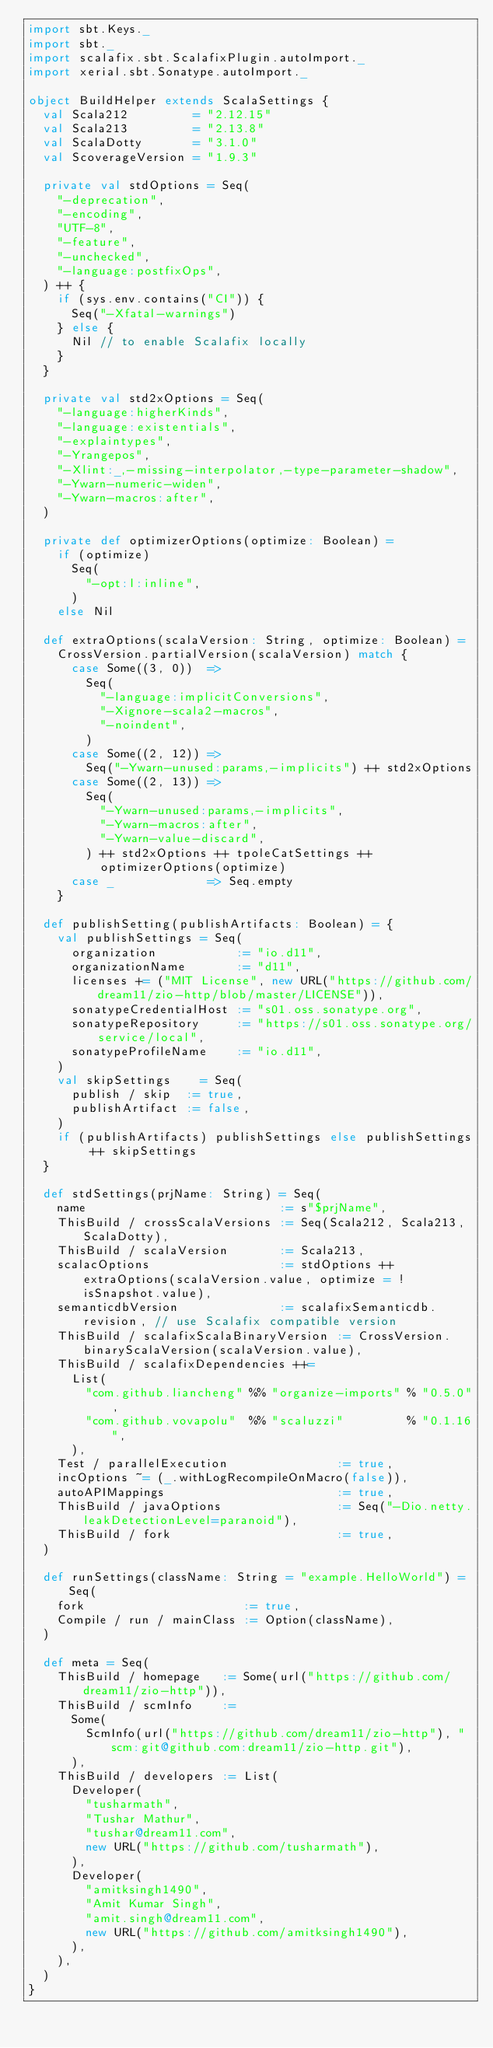<code> <loc_0><loc_0><loc_500><loc_500><_Scala_>import sbt.Keys._
import sbt._
import scalafix.sbt.ScalafixPlugin.autoImport._
import xerial.sbt.Sonatype.autoImport._

object BuildHelper extends ScalaSettings {
  val Scala212         = "2.12.15"
  val Scala213         = "2.13.8"
  val ScalaDotty       = "3.1.0"
  val ScoverageVersion = "1.9.3"

  private val stdOptions = Seq(
    "-deprecation",
    "-encoding",
    "UTF-8",
    "-feature",
    "-unchecked",
    "-language:postfixOps",
  ) ++ {
    if (sys.env.contains("CI")) {
      Seq("-Xfatal-warnings")
    } else {
      Nil // to enable Scalafix locally
    }
  }

  private val std2xOptions = Seq(
    "-language:higherKinds",
    "-language:existentials",
    "-explaintypes",
    "-Yrangepos",
    "-Xlint:_,-missing-interpolator,-type-parameter-shadow",
    "-Ywarn-numeric-widen",
    "-Ywarn-macros:after",
  )

  private def optimizerOptions(optimize: Boolean) =
    if (optimize)
      Seq(
        "-opt:l:inline",
      )
    else Nil

  def extraOptions(scalaVersion: String, optimize: Boolean) =
    CrossVersion.partialVersion(scalaVersion) match {
      case Some((3, 0))  =>
        Seq(
          "-language:implicitConversions",
          "-Xignore-scala2-macros",
          "-noindent",
        )
      case Some((2, 12)) =>
        Seq("-Ywarn-unused:params,-implicits") ++ std2xOptions
      case Some((2, 13)) =>
        Seq(
          "-Ywarn-unused:params,-implicits",
          "-Ywarn-macros:after",
          "-Ywarn-value-discard",
        ) ++ std2xOptions ++ tpoleCatSettings ++
          optimizerOptions(optimize)
      case _             => Seq.empty
    }

  def publishSetting(publishArtifacts: Boolean) = {
    val publishSettings = Seq(
      organization           := "io.d11",
      organizationName       := "d11",
      licenses += ("MIT License", new URL("https://github.com/dream11/zio-http/blob/master/LICENSE")),
      sonatypeCredentialHost := "s01.oss.sonatype.org",
      sonatypeRepository     := "https://s01.oss.sonatype.org/service/local",
      sonatypeProfileName    := "io.d11",
    )
    val skipSettings    = Seq(
      publish / skip  := true,
      publishArtifact := false,
    )
    if (publishArtifacts) publishSettings else publishSettings ++ skipSettings
  }

  def stdSettings(prjName: String) = Seq(
    name                           := s"$prjName",
    ThisBuild / crossScalaVersions := Seq(Scala212, Scala213, ScalaDotty),
    ThisBuild / scalaVersion       := Scala213,
    scalacOptions                  := stdOptions ++ extraOptions(scalaVersion.value, optimize = !isSnapshot.value),
    semanticdbVersion              := scalafixSemanticdb.revision, // use Scalafix compatible version
    ThisBuild / scalafixScalaBinaryVersion := CrossVersion.binaryScalaVersion(scalaVersion.value),
    ThisBuild / scalafixDependencies ++=
      List(
        "com.github.liancheng" %% "organize-imports" % "0.5.0",
        "com.github.vovapolu"  %% "scaluzzi"         % "0.1.16",
      ),
    Test / parallelExecution               := true,
    incOptions ~= (_.withLogRecompileOnMacro(false)),
    autoAPIMappings                        := true,
    ThisBuild / javaOptions                := Seq("-Dio.netty.leakDetectionLevel=paranoid"),
    ThisBuild / fork                       := true,
  )

  def runSettings(className: String = "example.HelloWorld") = Seq(
    fork                      := true,
    Compile / run / mainClass := Option(className),
  )

  def meta = Seq(
    ThisBuild / homepage   := Some(url("https://github.com/dream11/zio-http")),
    ThisBuild / scmInfo    :=
      Some(
        ScmInfo(url("https://github.com/dream11/zio-http"), "scm:git@github.com:dream11/zio-http.git"),
      ),
    ThisBuild / developers := List(
      Developer(
        "tusharmath",
        "Tushar Mathur",
        "tushar@dream11.com",
        new URL("https://github.com/tusharmath"),
      ),
      Developer(
        "amitksingh1490",
        "Amit Kumar Singh",
        "amit.singh@dream11.com",
        new URL("https://github.com/amitksingh1490"),
      ),
    ),
  )
}
</code> 